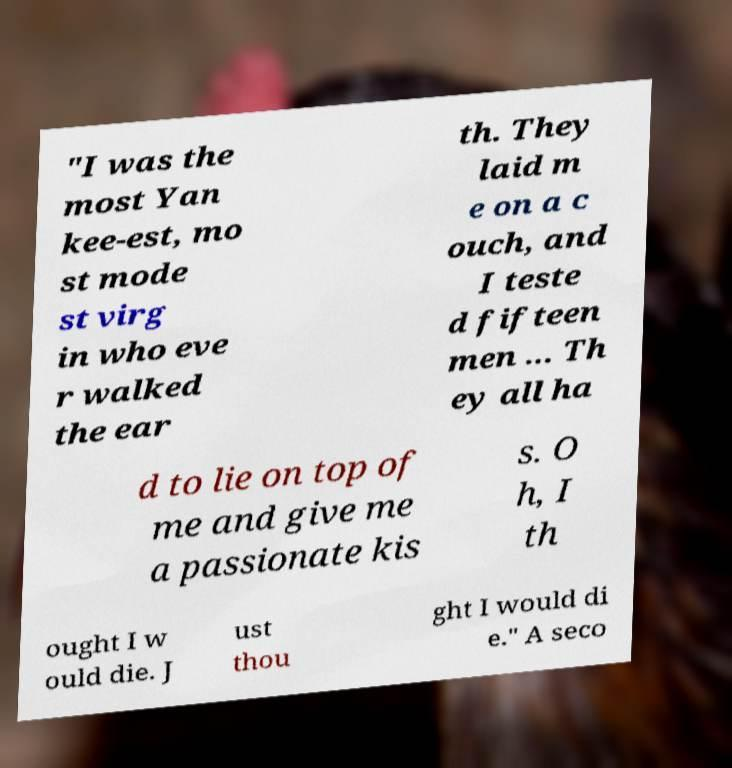Could you assist in decoding the text presented in this image and type it out clearly? "I was the most Yan kee-est, mo st mode st virg in who eve r walked the ear th. They laid m e on a c ouch, and I teste d fifteen men ... Th ey all ha d to lie on top of me and give me a passionate kis s. O h, I th ought I w ould die. J ust thou ght I would di e." A seco 